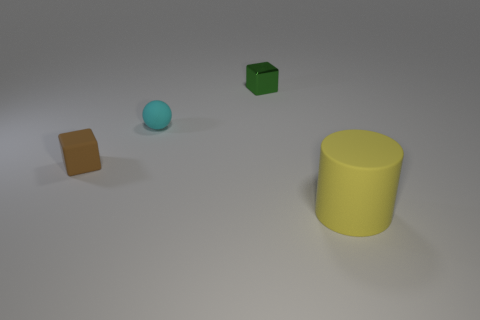Are there any other things that have the same material as the green cube?
Provide a succinct answer. No. What number of cyan objects are there?
Your answer should be compact. 1. Is the brown block made of the same material as the object on the right side of the tiny green shiny thing?
Provide a short and direct response. Yes. What number of brown objects are either big cylinders or shiny blocks?
Provide a short and direct response. 0. There is a brown object that is made of the same material as the cyan object; what is its size?
Give a very brief answer. Small. How many green metal objects have the same shape as the large yellow thing?
Offer a terse response. 0. Is the number of large yellow objects that are in front of the big yellow rubber thing greater than the number of small shiny things on the left side of the green object?
Provide a short and direct response. No. There is a shiny block; is it the same color as the block that is in front of the metallic object?
Offer a terse response. No. There is a brown object that is the same size as the cyan ball; what is it made of?
Provide a short and direct response. Rubber. How many things are tiny matte spheres or small rubber objects behind the small brown matte cube?
Keep it short and to the point. 1. 